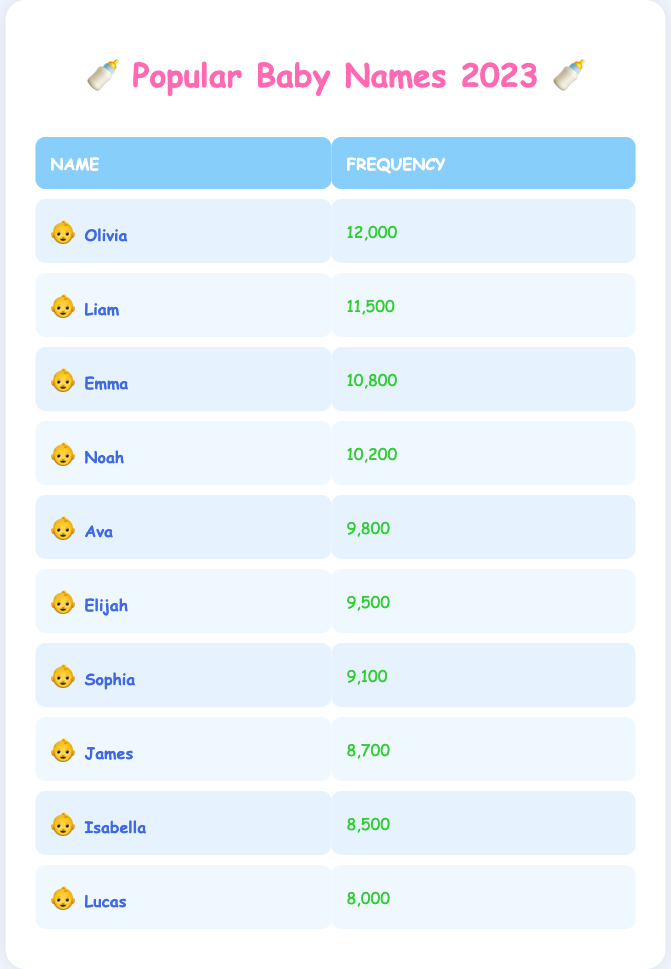What is the most popular baby name in 2023? The first entry in the table lists Olivia with a frequency of 12,000, indicating it is the most popular name.
Answer: Olivia How many times was the name Liam chosen? The frequency for Liam is listed as 11,500 in the table.
Answer: 11,500 Is the name Ava more popular than Isabella? Ava's frequency is 9,800, while Isabella's frequency is 8,500. Since 9,800 is greater than 8,500, Ava is indeed more popular.
Answer: Yes What is the total frequency of the top three baby names? The frequencies of the top three names are Olivia (12,000), Liam (11,500), and Emma (10,800). Summing these gives us 12,000 + 11,500 + 10,800 = 34,300.
Answer: 34,300 What percentage of the total frequency is represented by the name Noah? To find Noah's percentage, first we add the frequencies for all names, which is 12,000 + 11,500 + 10,800 + 10,200 + 9,800 + 9,500 + 9,100 + 8,700 + 8,500 + 8,000 = 88,600. Noah's frequency is 10,200, so the percentage is (10,200 / 88,600) * 100 = 11.52%.
Answer: 11.52% Which name has a frequency that is closest to 9,000? From the listed frequencies, Sophia has a frequency of 9,100, which is the closest to 9,000, as all others are either higher or lower by a larger margin.
Answer: Sophia How many names have a frequency greater than 9,000? The names with frequencies greater than 9,000 are Olivia, Liam, Emma, Noah, and Ava, which gives us a count of five names.
Answer: 5 Are there any names with a frequency less than 9,000? Checking the frequencies, Lucas has a frequency of 8,000, which is less than 9,000. Therefore, this statement is true.
Answer: Yes 